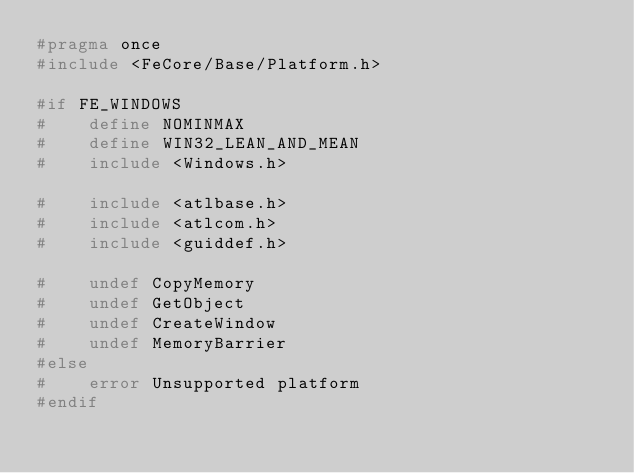<code> <loc_0><loc_0><loc_500><loc_500><_C_>#pragma once
#include <FeCore/Base/Platform.h>

#if FE_WINDOWS
#    define NOMINMAX
#    define WIN32_LEAN_AND_MEAN
#    include <Windows.h>

#    include <atlbase.h>
#    include <atlcom.h>
#    include <guiddef.h>

#    undef CopyMemory
#    undef GetObject
#    undef CreateWindow
#    undef MemoryBarrier
#else
#    error Unsupported platform
#endif
</code> 